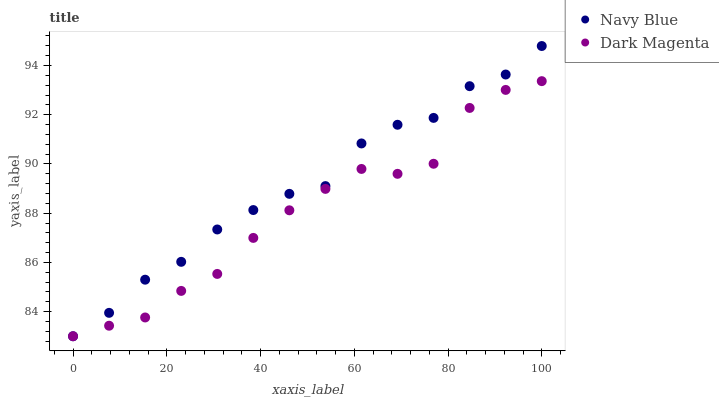Does Dark Magenta have the minimum area under the curve?
Answer yes or no. Yes. Does Navy Blue have the maximum area under the curve?
Answer yes or no. Yes. Does Dark Magenta have the maximum area under the curve?
Answer yes or no. No. Is Navy Blue the smoothest?
Answer yes or no. Yes. Is Dark Magenta the roughest?
Answer yes or no. Yes. Is Dark Magenta the smoothest?
Answer yes or no. No. Does Navy Blue have the lowest value?
Answer yes or no. Yes. Does Navy Blue have the highest value?
Answer yes or no. Yes. Does Dark Magenta have the highest value?
Answer yes or no. No. Does Navy Blue intersect Dark Magenta?
Answer yes or no. Yes. Is Navy Blue less than Dark Magenta?
Answer yes or no. No. Is Navy Blue greater than Dark Magenta?
Answer yes or no. No. 